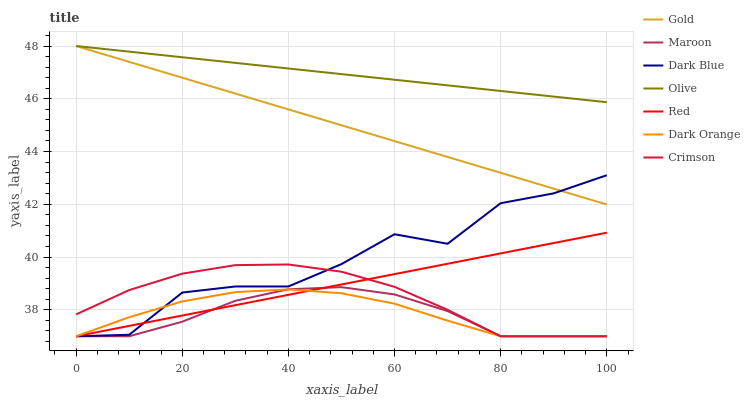Does Maroon have the minimum area under the curve?
Answer yes or no. Yes. Does Olive have the maximum area under the curve?
Answer yes or no. Yes. Does Gold have the minimum area under the curve?
Answer yes or no. No. Does Gold have the maximum area under the curve?
Answer yes or no. No. Is Gold the smoothest?
Answer yes or no. Yes. Is Dark Blue the roughest?
Answer yes or no. Yes. Is Maroon the smoothest?
Answer yes or no. No. Is Maroon the roughest?
Answer yes or no. No. Does Dark Orange have the lowest value?
Answer yes or no. Yes. Does Gold have the lowest value?
Answer yes or no. No. Does Olive have the highest value?
Answer yes or no. Yes. Does Maroon have the highest value?
Answer yes or no. No. Is Maroon less than Olive?
Answer yes or no. Yes. Is Olive greater than Dark Orange?
Answer yes or no. Yes. Does Crimson intersect Red?
Answer yes or no. Yes. Is Crimson less than Red?
Answer yes or no. No. Is Crimson greater than Red?
Answer yes or no. No. Does Maroon intersect Olive?
Answer yes or no. No. 